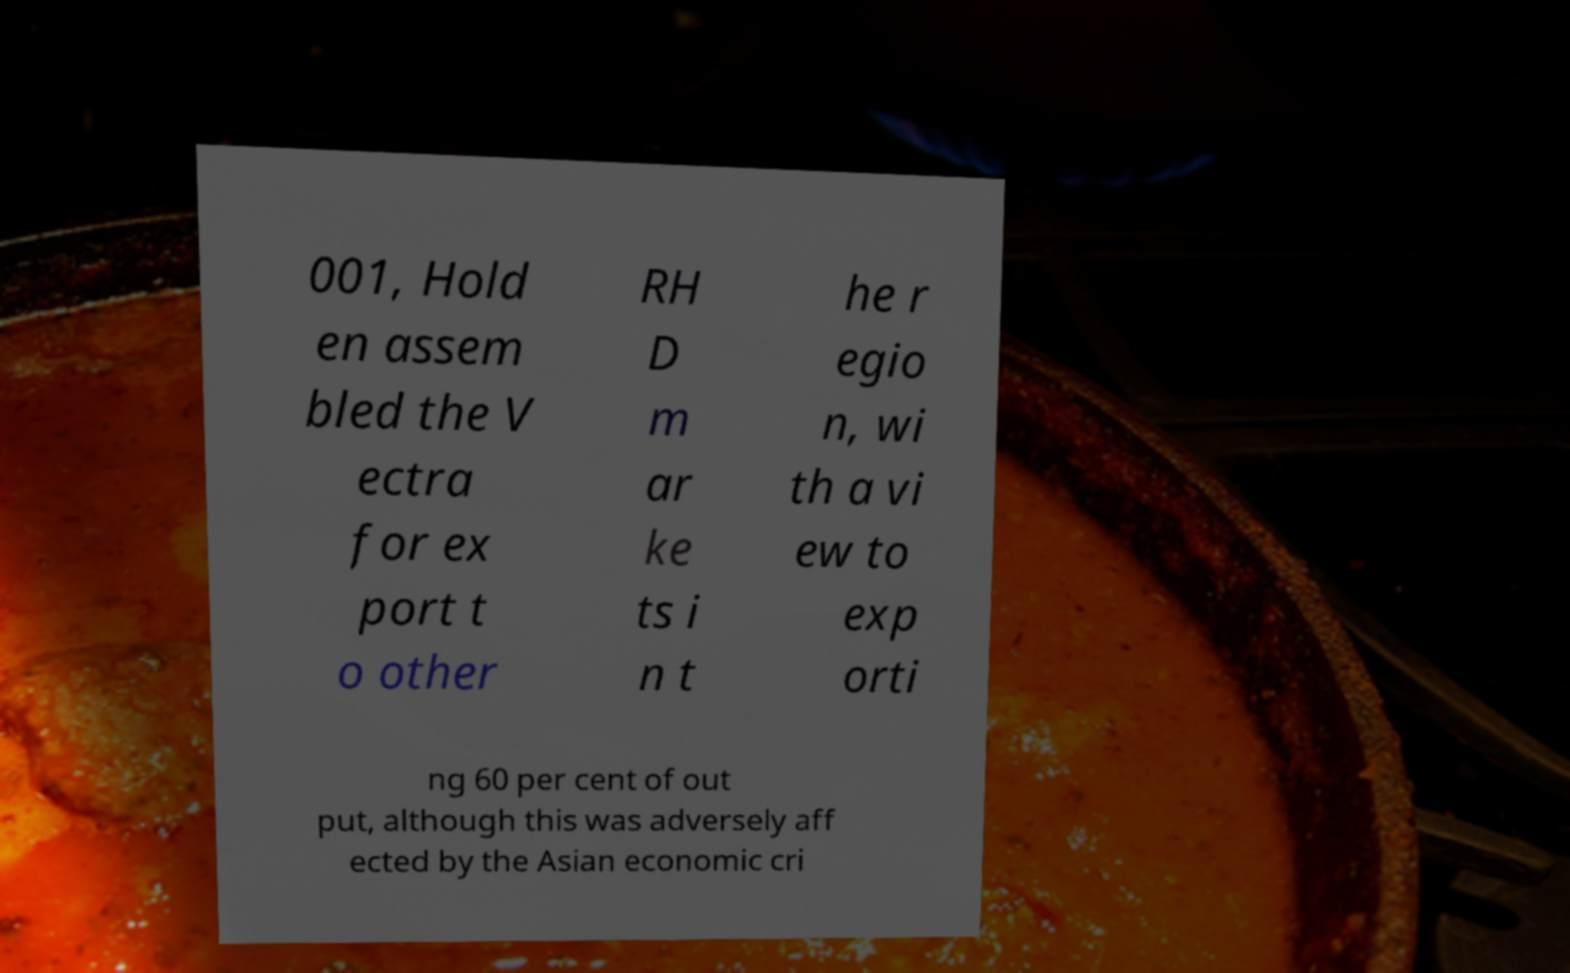What messages or text are displayed in this image? I need them in a readable, typed format. 001, Hold en assem bled the V ectra for ex port t o other RH D m ar ke ts i n t he r egio n, wi th a vi ew to exp orti ng 60 per cent of out put, although this was adversely aff ected by the Asian economic cri 